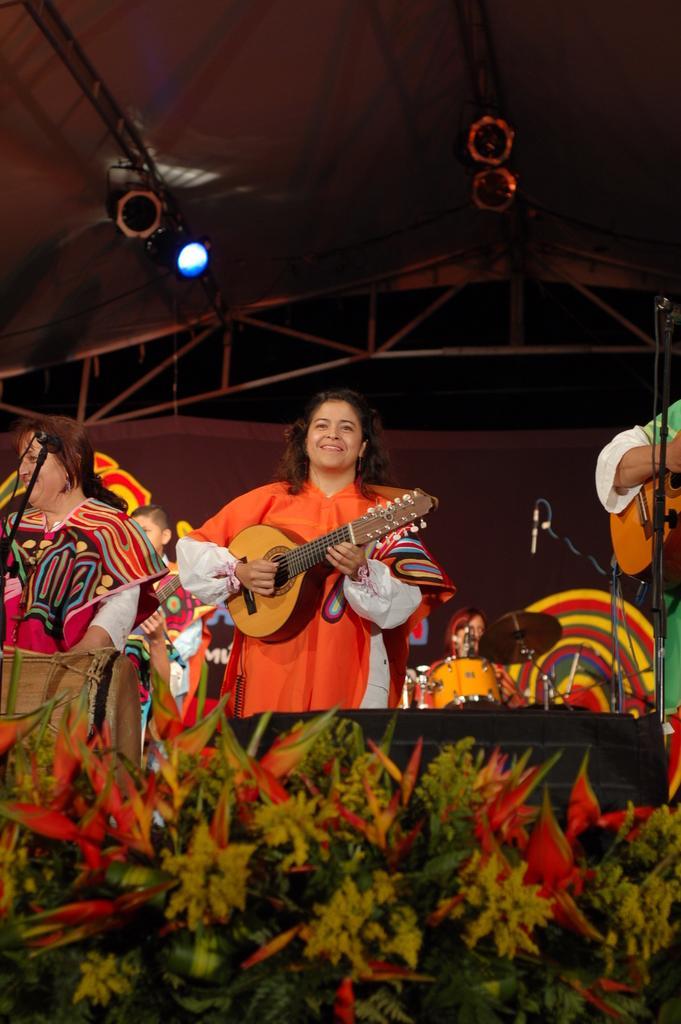Describe this image in one or two sentences. In this image there are some persons playing musical instruments. There are standing on the middle of the image. In the center there is a woman, she is wearing orange dress and smiling. Towards the left there is another women wearing colorful dress. Towards the right there is a person holding a guitar. In front of them there are some flowers. In the background there are some lights and people. 